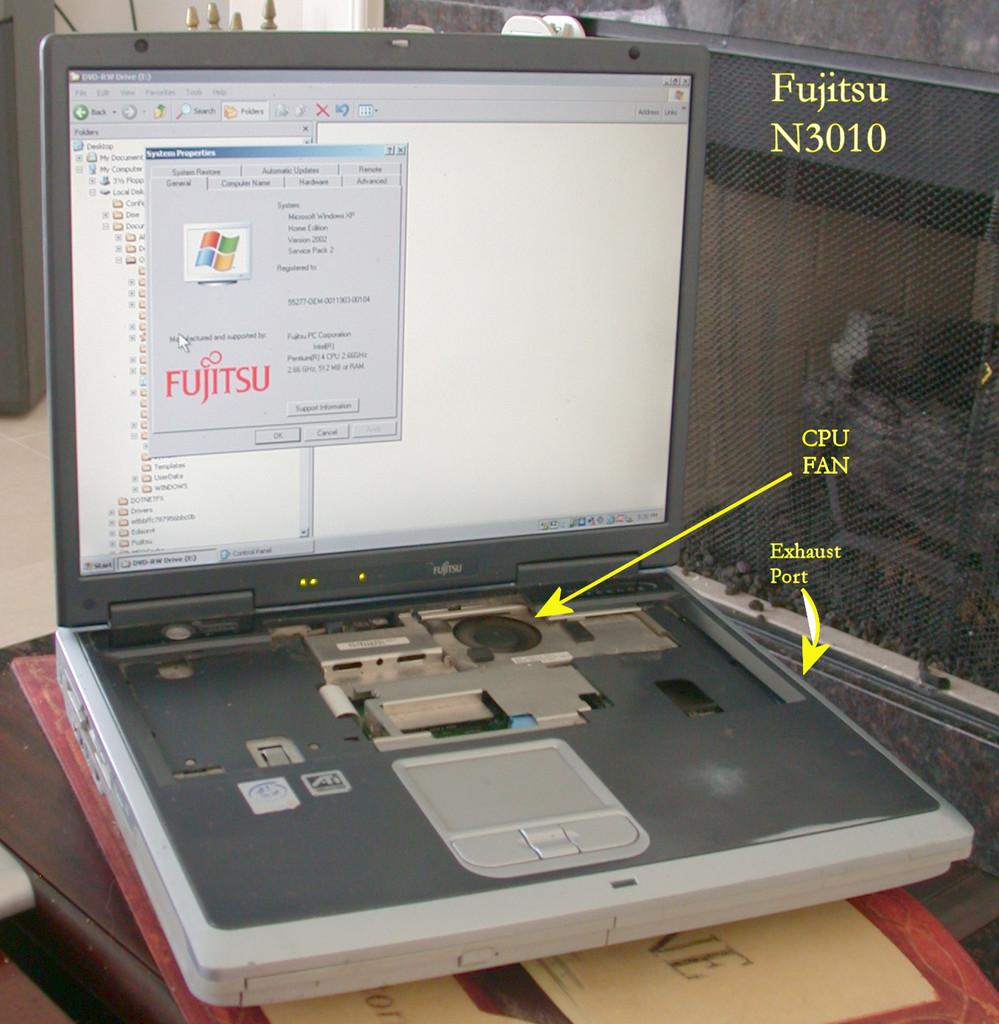<image>
Summarize the visual content of the image. A Fujitsu laptop is open and has the System Properties screen open. 